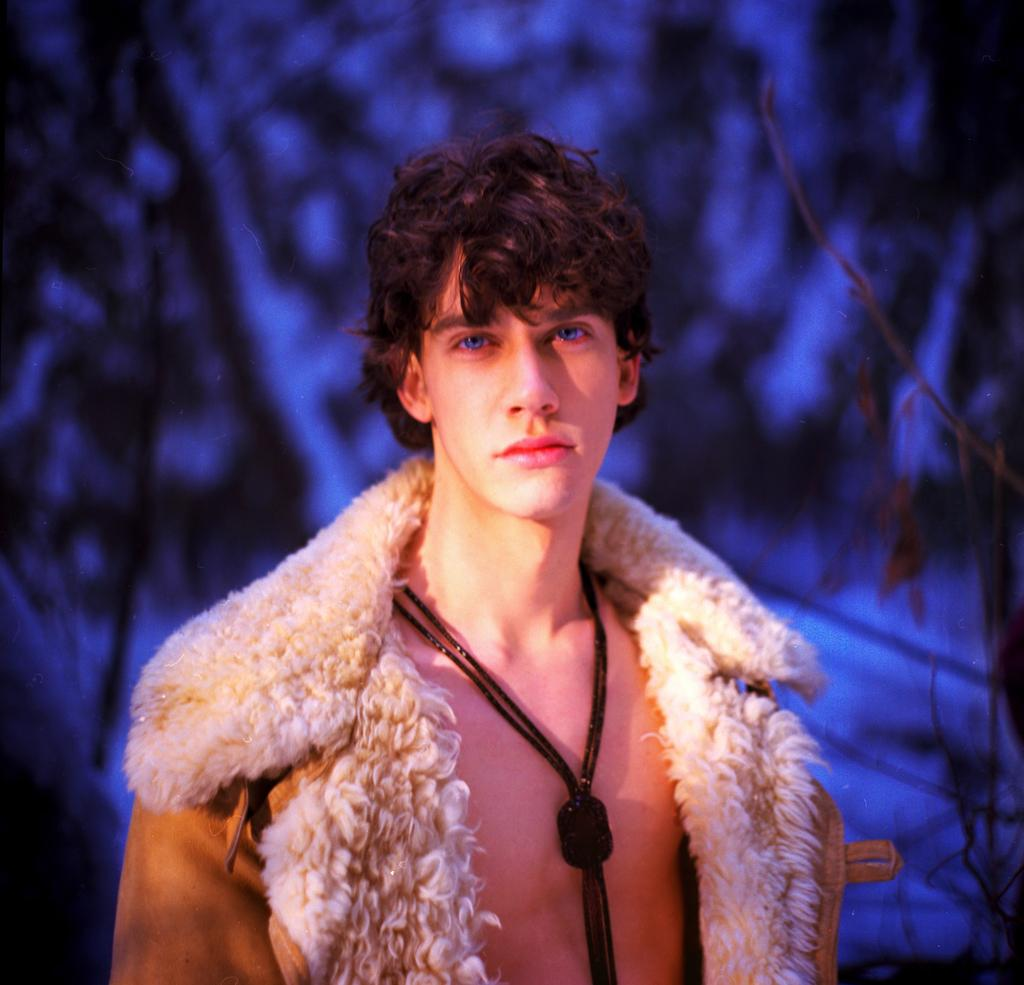Who or what is the main subject in the image? There is a person in the image. What is the person wearing? The person is wearing a dress. What can be seen in the background of the image? There are trees in the background of the image. Can you describe the colors in the background of the image? The background of the image includes blue and black colors. How many snails can be seen crawling on the person's dress in the image? There are no snails present in the image, so it is not possible to determine how many would be crawling on the person's dress. 